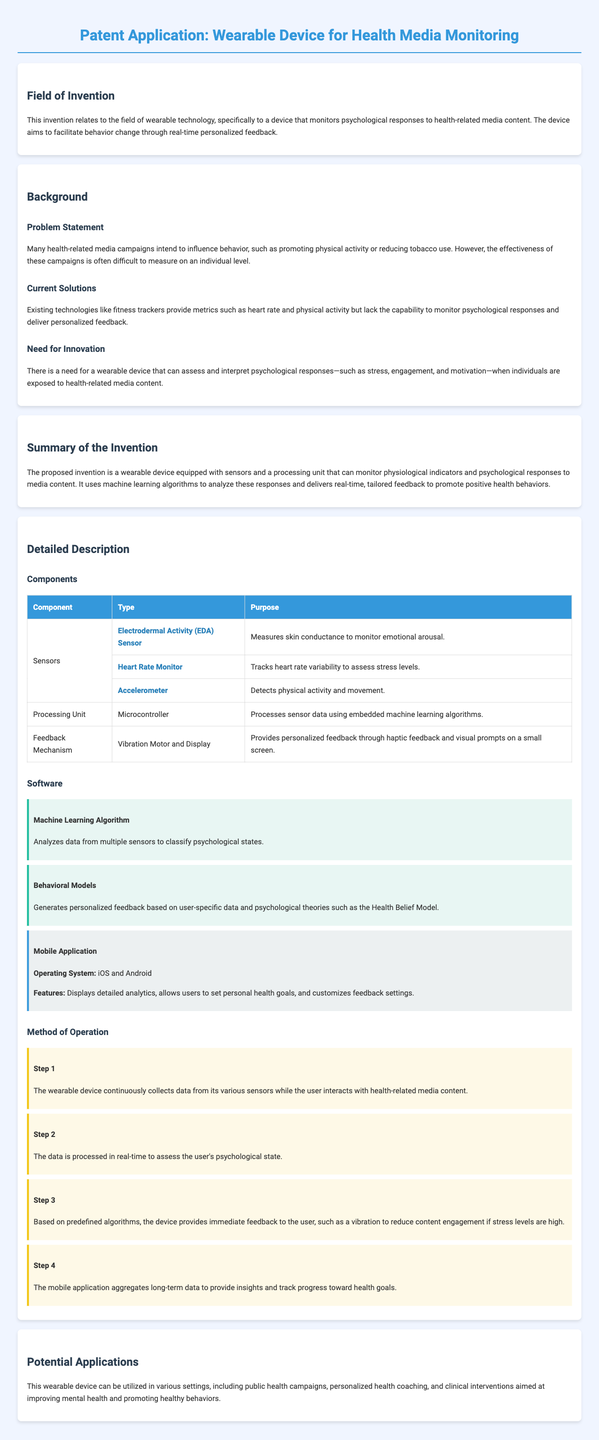What is the invention related to? The invention relates to wearable technology that monitors psychological responses to health-related media content.
Answer: Wearable technology What problem is addressed in the patent application? The problem addressed is the difficulty in measuring the effectiveness of health-related media campaigns on an individual level.
Answer: Effectiveness measurement What type of sensors are included in the device? The device includes Electrodermal Activity (EDA) Sensor, Heart Rate Monitor, and Accelerometer as sensors.
Answer: EDA Sensor, Heart Rate Monitor, Accelerometer What is the primary purpose of the feedback mechanism? The feedback mechanism's primary purpose is to provide personalized feedback through haptic feedback and visual prompts.
Answer: Personalized feedback What does the mobile application allow users to do? The mobile application allows users to set personal health goals.
Answer: Set personal health goals What does the machine learning algorithm analyze? The machine learning algorithm analyzes data from multiple sensors to classify psychological states.
Answer: Psychological states What step involves continuous data collection? Step 1 involves the wearable device continuously collecting data while the user interacts with media content.
Answer: Step 1 In which settings can the wearable device be utilized? The wearable device can be utilized in public health campaigns, personalized health coaching, and clinical interventions.
Answer: Various settings 